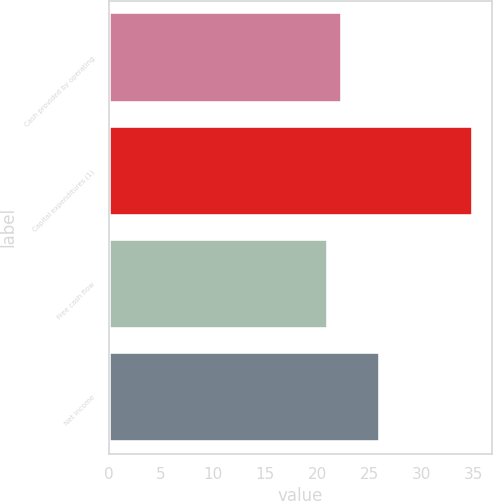Convert chart. <chart><loc_0><loc_0><loc_500><loc_500><bar_chart><fcel>Cash provided by operating<fcel>Capital expenditures (1)<fcel>Free cash flow<fcel>Net income<nl><fcel>22.4<fcel>35<fcel>21<fcel>26<nl></chart> 